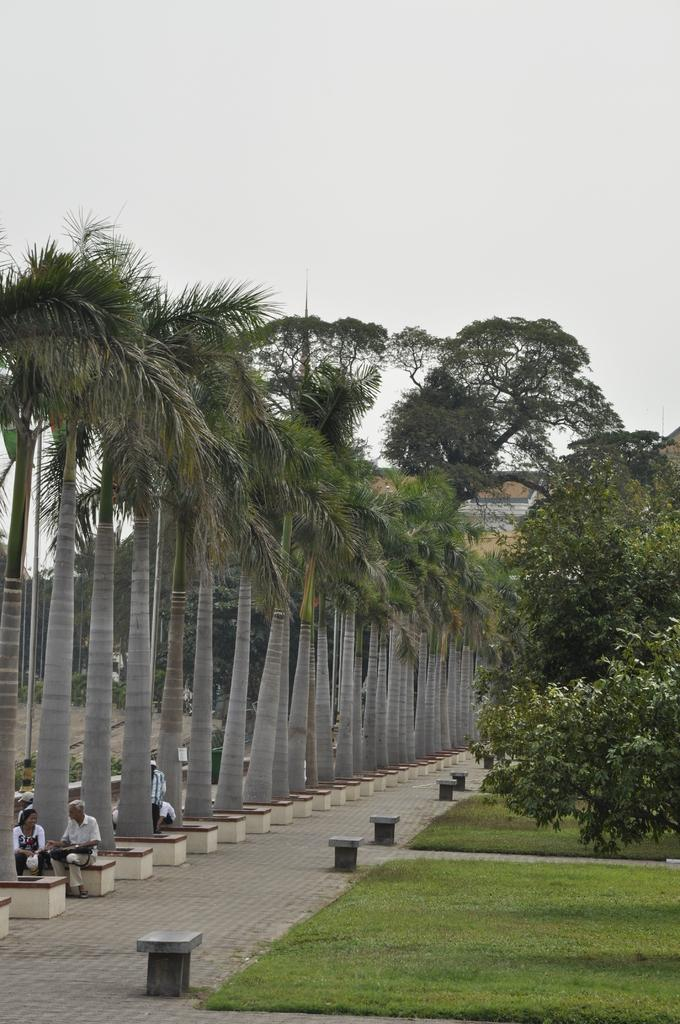How many people are sitting in the image? There are two persons sitting in the image. What can be seen in the background of the image? There are trees and a building in the background of the image. What is the color of the trees in the image? The trees are green. What is the color of the building in the image? The building is yellow. What is visible above the trees and building in the image? The sky is visible in the image. What is the color of the sky in the image? The sky is white. What type of zinc is being offered in the class depicted in the image? There is no zinc or class present in the image; it features two persons sitting with trees, a building, and a white sky in the background. 